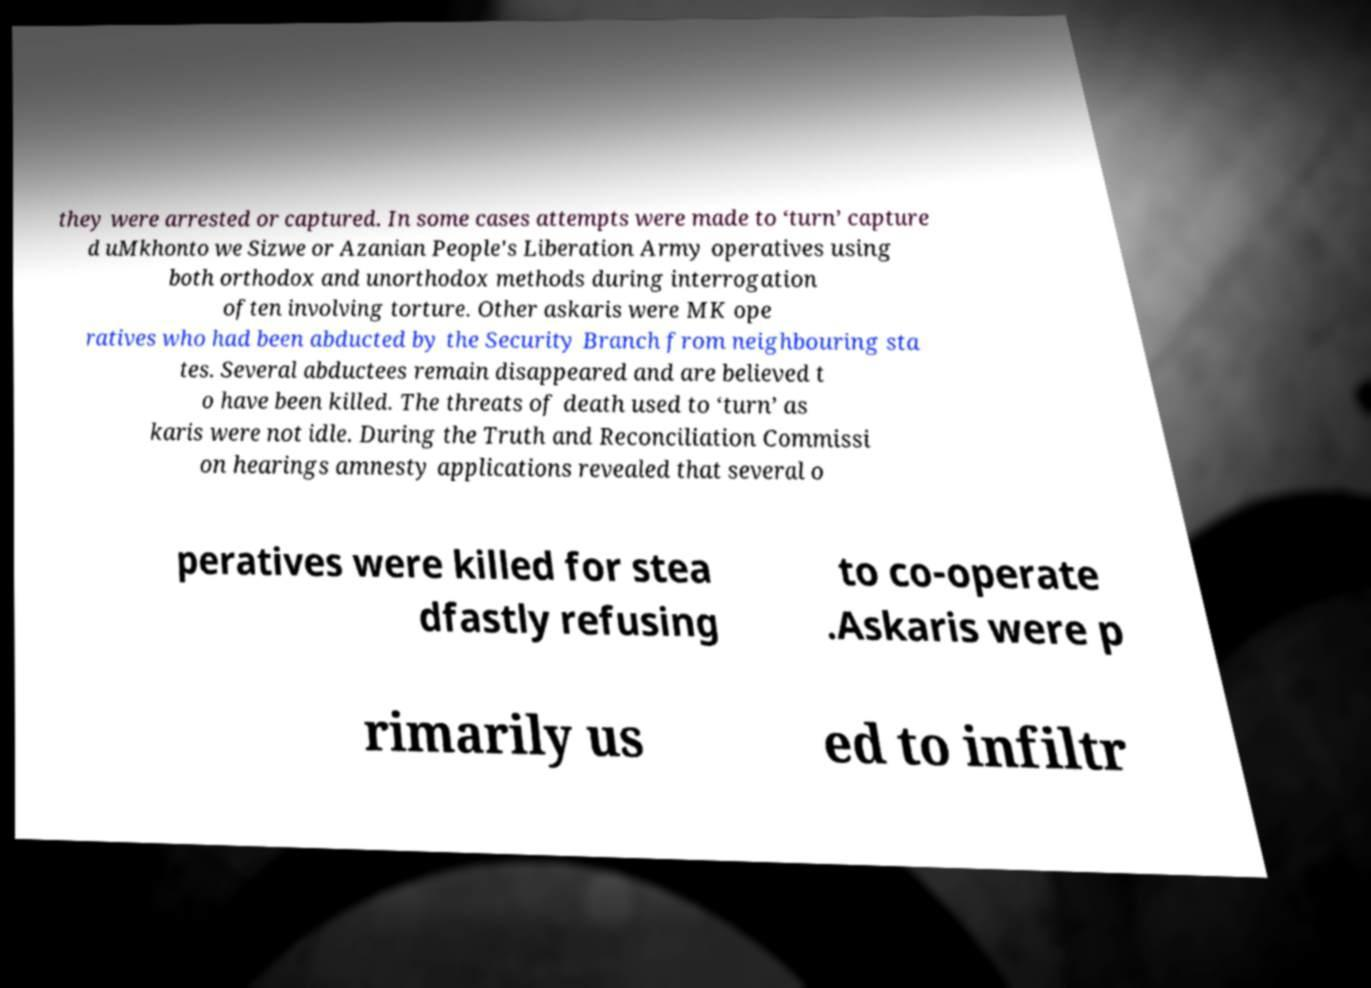Please read and relay the text visible in this image. What does it say? they were arrested or captured. In some cases attempts were made to ‘turn’ capture d uMkhonto we Sizwe or Azanian People's Liberation Army operatives using both orthodox and unorthodox methods during interrogation often involving torture. Other askaris were MK ope ratives who had been abducted by the Security Branch from neighbouring sta tes. Several abductees remain disappeared and are believed t o have been killed. The threats of death used to ‘turn’ as karis were not idle. During the Truth and Reconciliation Commissi on hearings amnesty applications revealed that several o peratives were killed for stea dfastly refusing to co-operate .Askaris were p rimarily us ed to infiltr 